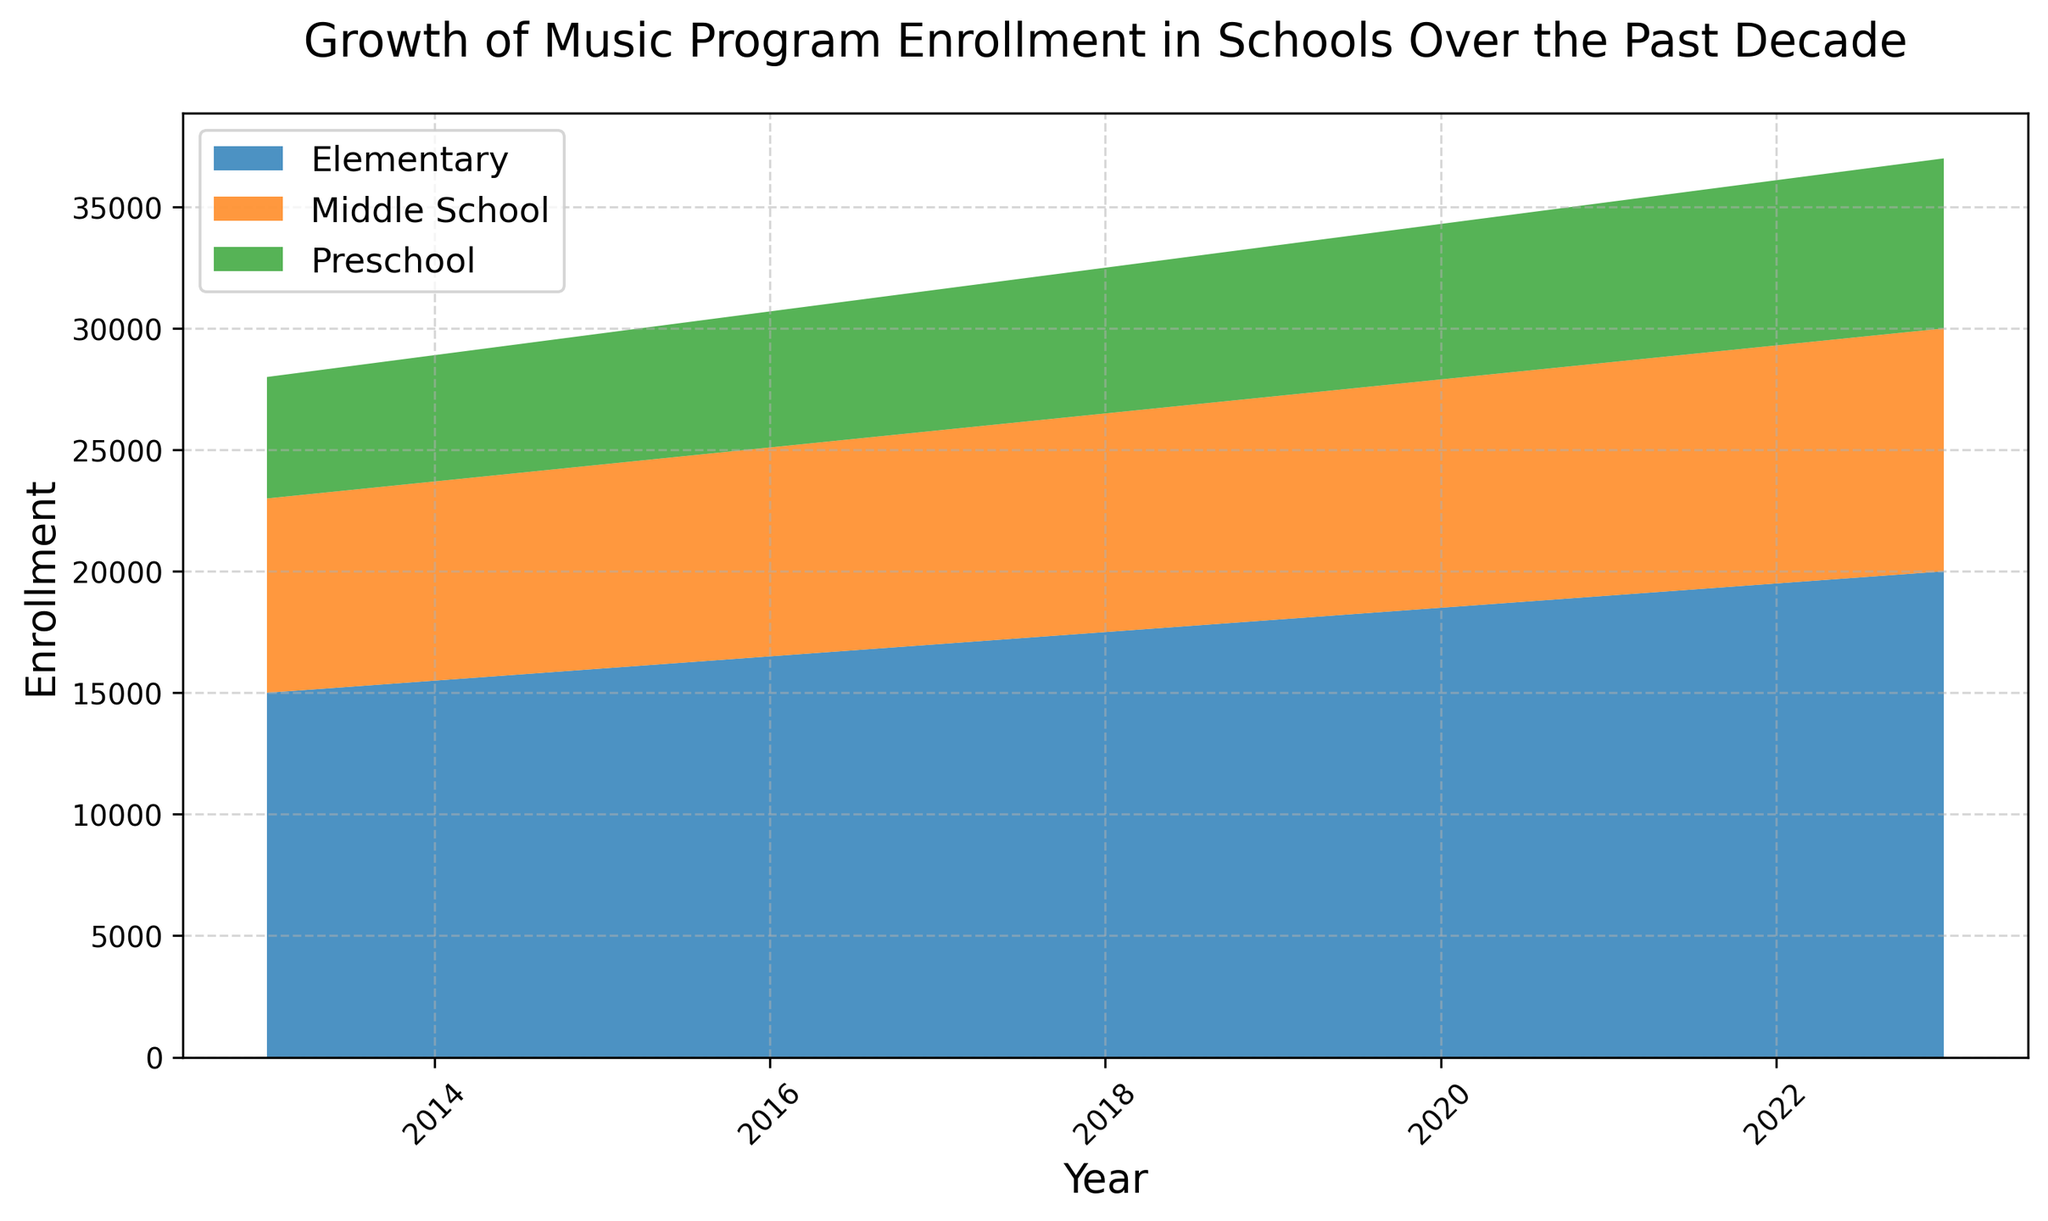What is the total enrollment in music programs for Preschool in 2023? By looking at the plot, the enrollment for Preschool in 2023 is indicated around 7000 by the height of the area specifically shaded for Preschool. This is confirmed by the data as well.
Answer: 7000 Which educational level had the highest growth in music program enrollment from 2013 to 2023? To determine this, we can visually compare the increase in the height of the areas representing the educational levels from 2013 to 2023. Elementary shows the largest increment in height, indicating the most significant growth.
Answer: Elementary What was the combined enrollment for all educational levels in 2023? By adding the highest points of all areas in the plot for 2023: Preschool (7000), Elementary (20000), and Middle School (10000), we get 7000 + 20000 + 10000 = 37000.
Answer: 37000 In which year did Middle School's enrollment reach 9000? By observing where the specific area representing Middle School reaches the approximate enrollment of 9000 in the plot, we can see that this occurs in 2018.
Answer: 2018 Compare the growth in enrollments between Elementary and Middle School from 2013 to 2018. Which grew more? By subtracting their 2013 enrollments from their 2018 enrollments: Elementary (17500 - 15000 = 2500) and Middle School (9000 - 8000 = 1000), Elementary grew by 2500, while Middle School grew by 1000.
Answer: Elementary In 2015, what was the total enrollment combining all three educational levels? Summing up the enrollments from the plot for 2015: Preschool (5400), Elementary (16000), and Middle School (8400), we get 5400 + 16000 + 8400 = 29800.
Answer: 29800 What trend is observed in the Preschool enrollment from 2013 to 2023? The plot shows an increasing trend in the height of the area representing Preschool from 2013 to 2023, showing continuous growth.
Answer: Increasing Between 2020 and 2023, did any educational level's enrollment stop increasing or decrease? By observing the slopes of each educational level's area between 2020 and 2023, no educational level's area decreases; all show a continuous increase.
Answer: No Which year saw Elementary's enrollment surpass 18000? The plot shows that the Elementary area surpasses 18000 in the year 2019.
Answer: 2019 